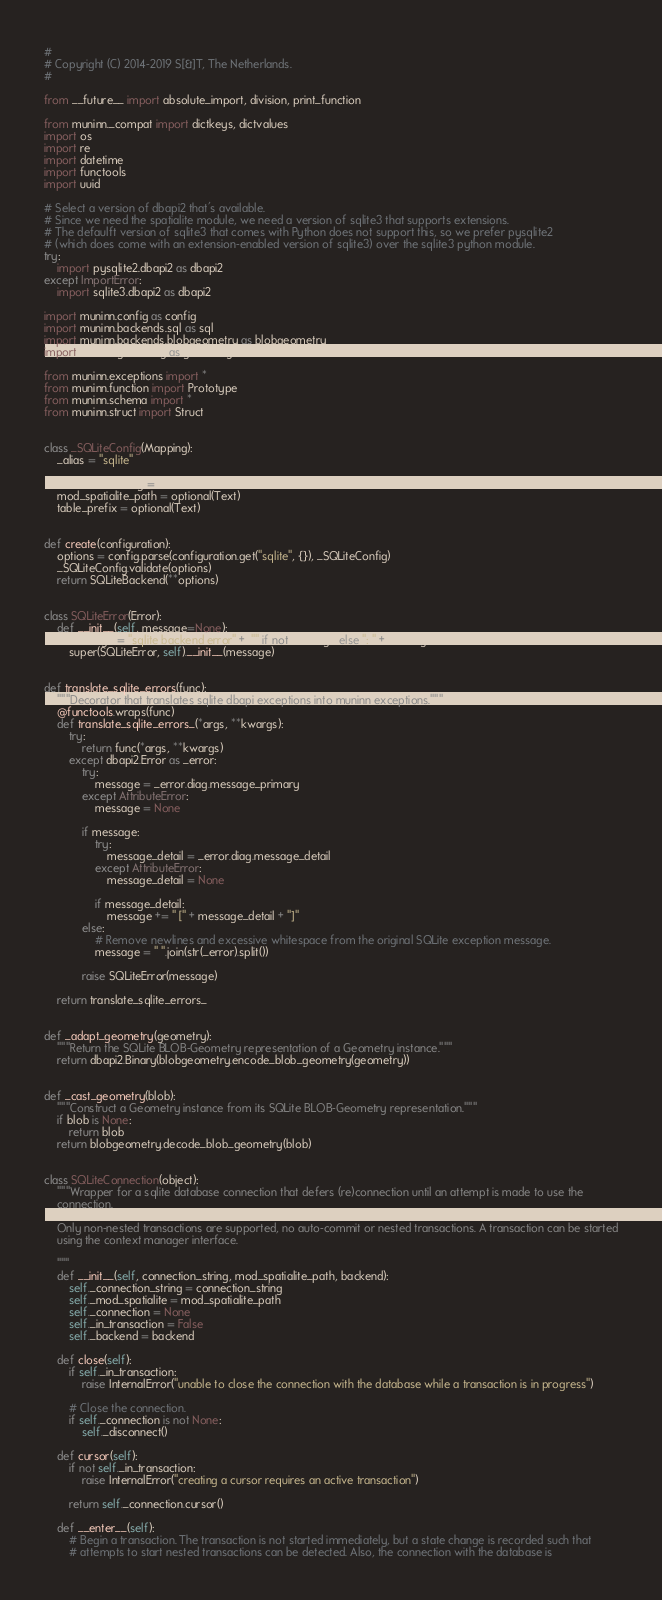<code> <loc_0><loc_0><loc_500><loc_500><_Python_>#
# Copyright (C) 2014-2019 S[&]T, The Netherlands.
#

from __future__ import absolute_import, division, print_function

from muninn._compat import dictkeys, dictvalues
import os
import re
import datetime
import functools
import uuid

# Select a version of dbapi2 that's available.
# Since we need the spatialite module, we need a version of sqlite3 that supports extensions.
# The defaulft version of sqlite3 that comes with Python does not support this, so we prefer pysqlite2
# (which does come with an extension-enabled version of sqlite3) over the sqlite3 python module.
try:
    import pysqlite2.dbapi2 as dbapi2
except ImportError:
    import sqlite3.dbapi2 as dbapi2

import muninn.config as config
import muninn.backends.sql as sql
import muninn.backends.blobgeometry as blobgeometry
import muninn.geometry as geometry

from muninn.exceptions import *
from muninn.function import Prototype
from muninn.schema import *
from muninn.struct import Struct


class _SQLiteConfig(Mapping):
    _alias = "sqlite"

    connection_string = Text
    mod_spatialite_path = optional(Text)
    table_prefix = optional(Text)


def create(configuration):
    options = config.parse(configuration.get("sqlite", {}), _SQLiteConfig)
    _SQLiteConfig.validate(options)
    return SQLiteBackend(**options)


class SQLiteError(Error):
    def __init__(self, message=None):
        message = "sqlite backend error" + ("" if not message else ": " + message)
        super(SQLiteError, self).__init__(message)


def translate_sqlite_errors(func):
    """Decorator that translates sqlite dbapi exceptions into muninn exceptions."""
    @functools.wraps(func)
    def translate_sqlite_errors_(*args, **kwargs):
        try:
            return func(*args, **kwargs)
        except dbapi2.Error as _error:
            try:
                message = _error.diag.message_primary
            except AttributeError:
                message = None

            if message:
                try:
                    message_detail = _error.diag.message_detail
                except AttributeError:
                    message_detail = None

                if message_detail:
                    message += " [" + message_detail + "]"
            else:
                # Remove newlines and excessive whitespace from the original SQLite exception message.
                message = " ".join(str(_error).split())

            raise SQLiteError(message)

    return translate_sqlite_errors_


def _adapt_geometry(geometry):
    """Return the SQLite BLOB-Geometry representation of a Geometry instance."""
    return dbapi2.Binary(blobgeometry.encode_blob_geometry(geometry))


def _cast_geometry(blob):
    """Construct a Geometry instance from its SQLite BLOB-Geometry representation."""
    if blob is None:
        return blob
    return blobgeometry.decode_blob_geometry(blob)


class SQLiteConnection(object):
    """Wrapper for a sqlite database connection that defers (re)connection until an attempt is made to use the
    connection.

    Only non-nested transactions are supported, no auto-commit or nested transactions. A transaction can be started
    using the context manager interface.

    """
    def __init__(self, connection_string, mod_spatialite_path, backend):
        self._connection_string = connection_string
        self._mod_spatialite = mod_spatialite_path
        self._connection = None
        self._in_transaction = False
        self._backend = backend

    def close(self):
        if self._in_transaction:
            raise InternalError("unable to close the connection with the database while a transaction is in progress")

        # Close the connection.
        if self._connection is not None:
            self._disconnect()

    def cursor(self):
        if not self._in_transaction:
            raise InternalError("creating a cursor requires an active transaction")

        return self._connection.cursor()

    def __enter__(self):
        # Begin a transaction. The transaction is not started immediately, but a state change is recorded such that
        # attempts to start nested transactions can be detected. Also, the connection with the database is</code> 